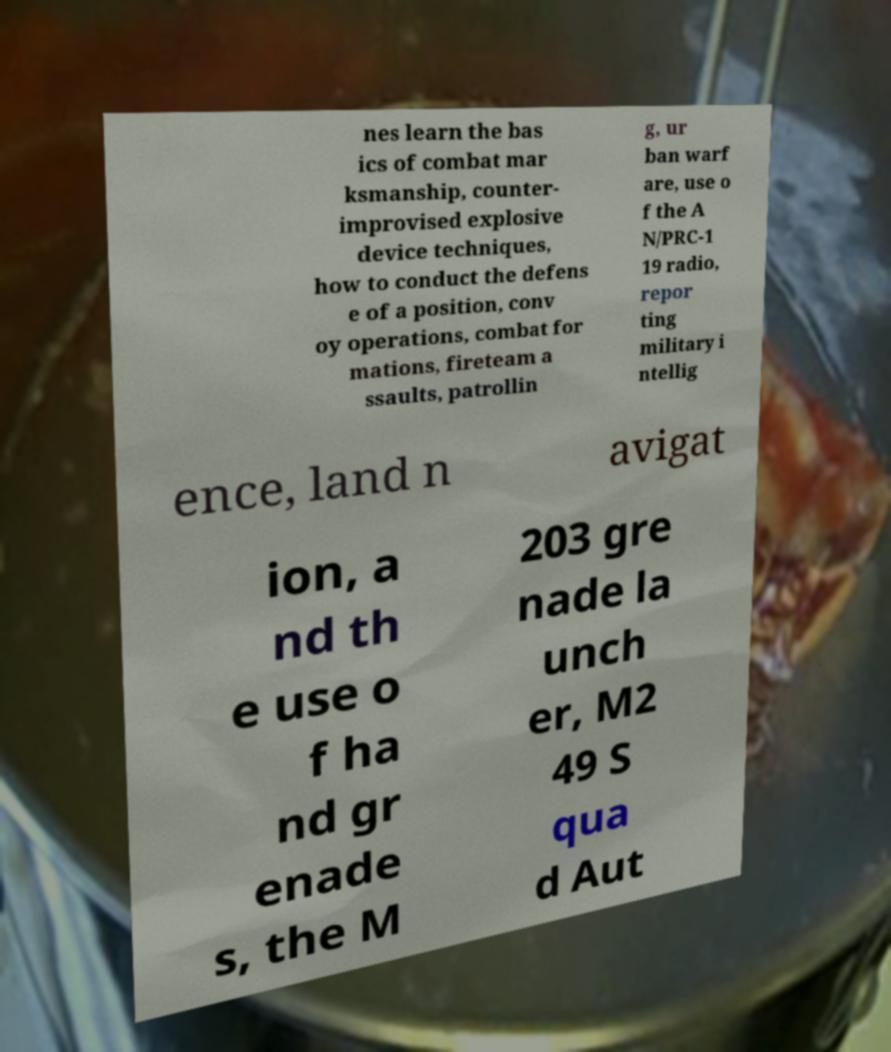Please read and relay the text visible in this image. What does it say? nes learn the bas ics of combat mar ksmanship, counter- improvised explosive device techniques, how to conduct the defens e of a position, conv oy operations, combat for mations, fireteam a ssaults, patrollin g, ur ban warf are, use o f the A N/PRC-1 19 radio, repor ting military i ntellig ence, land n avigat ion, a nd th e use o f ha nd gr enade s, the M 203 gre nade la unch er, M2 49 S qua d Aut 